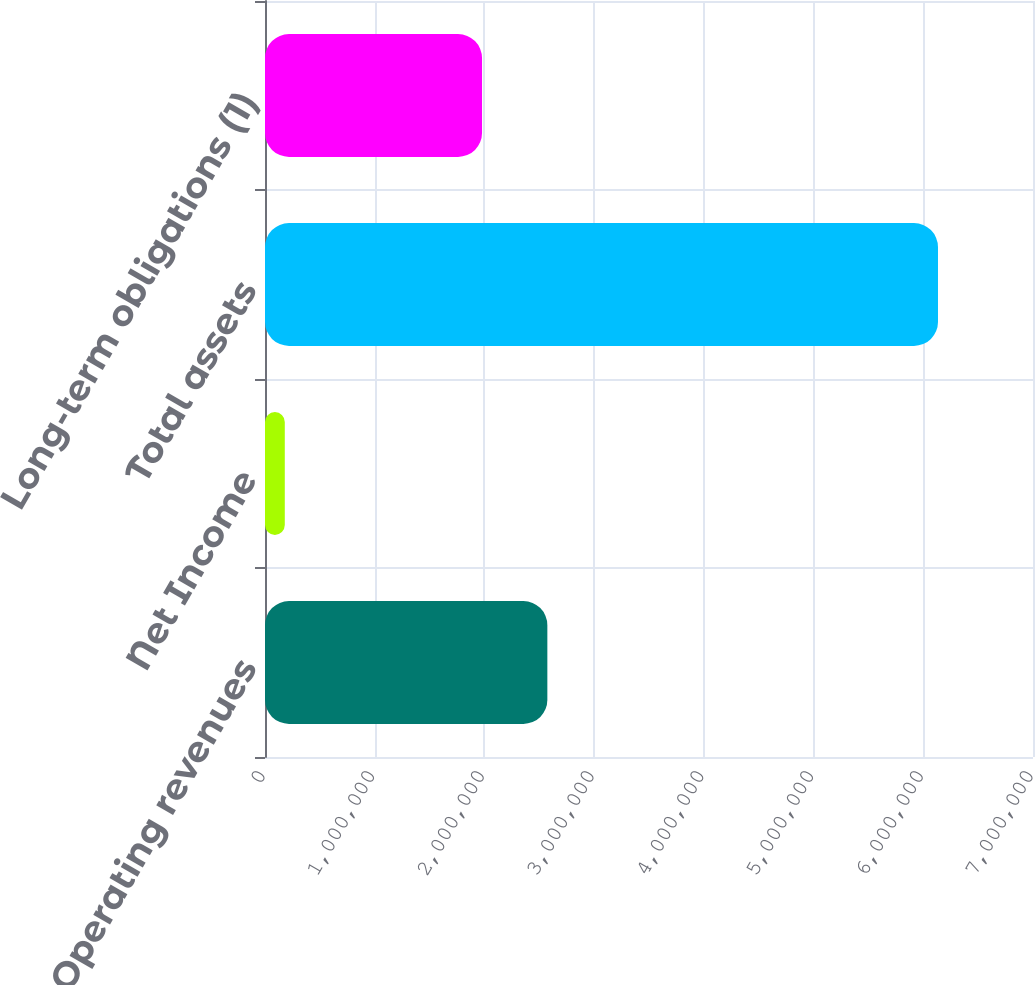<chart> <loc_0><loc_0><loc_500><loc_500><bar_chart><fcel>Operating revenues<fcel>Net Income<fcel>Total assets<fcel>Long-term obligations (1)<nl><fcel>2.57352e+06<fcel>180343<fcel>6.13402e+06<fcel>1.97815e+06<nl></chart> 